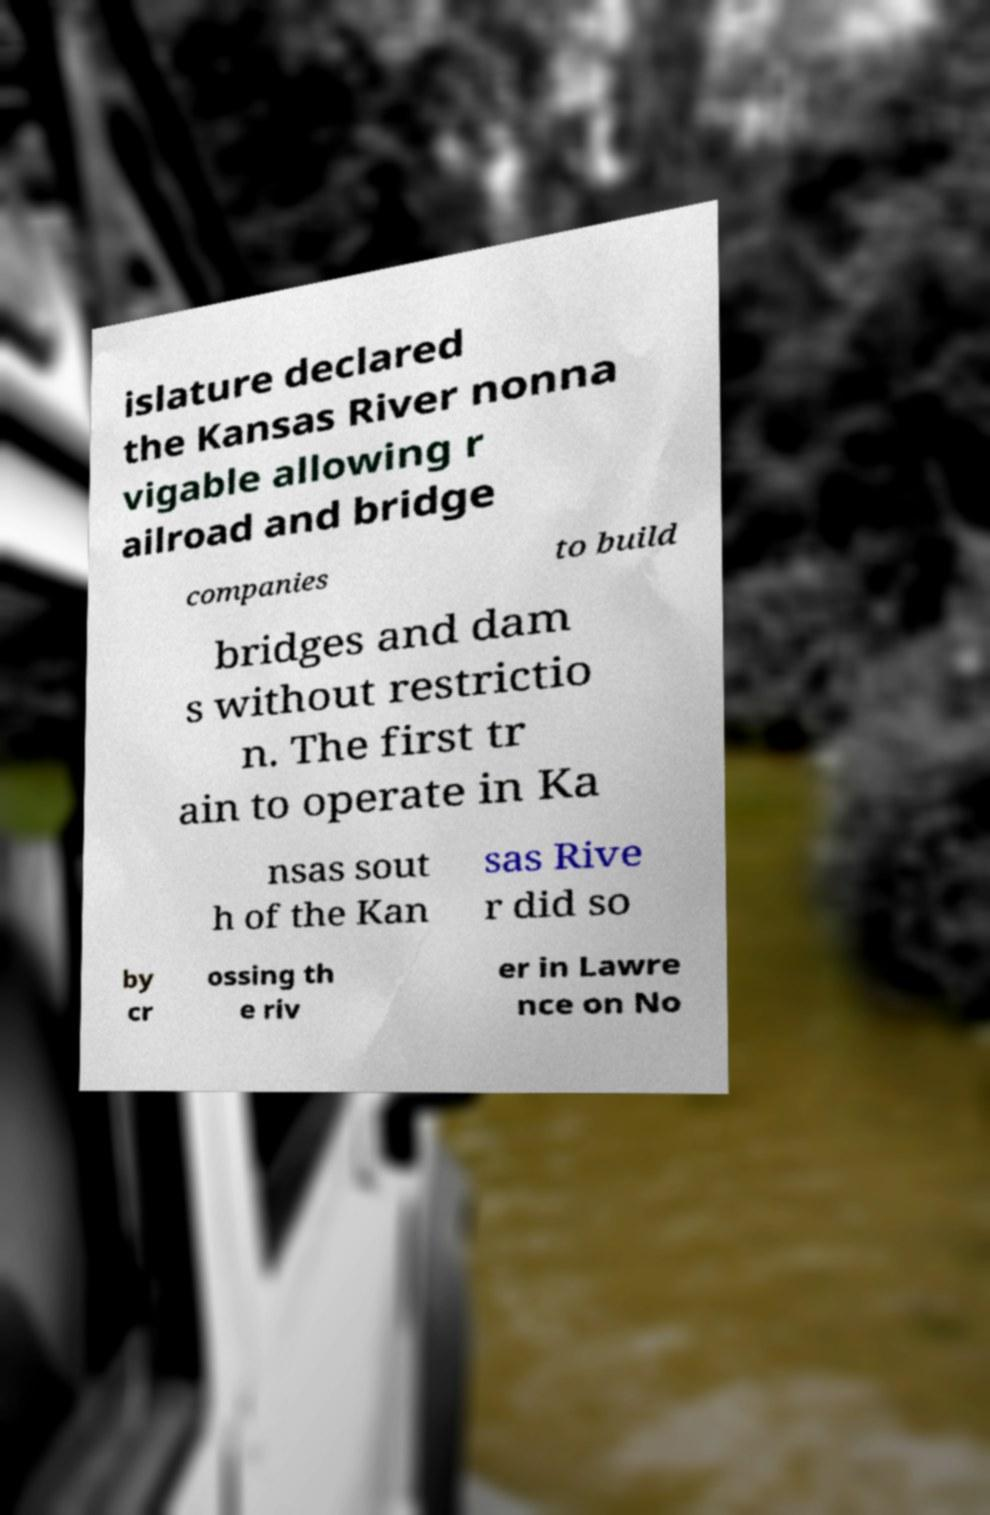Please read and relay the text visible in this image. What does it say? islature declared the Kansas River nonna vigable allowing r ailroad and bridge companies to build bridges and dam s without restrictio n. The first tr ain to operate in Ka nsas sout h of the Kan sas Rive r did so by cr ossing th e riv er in Lawre nce on No 